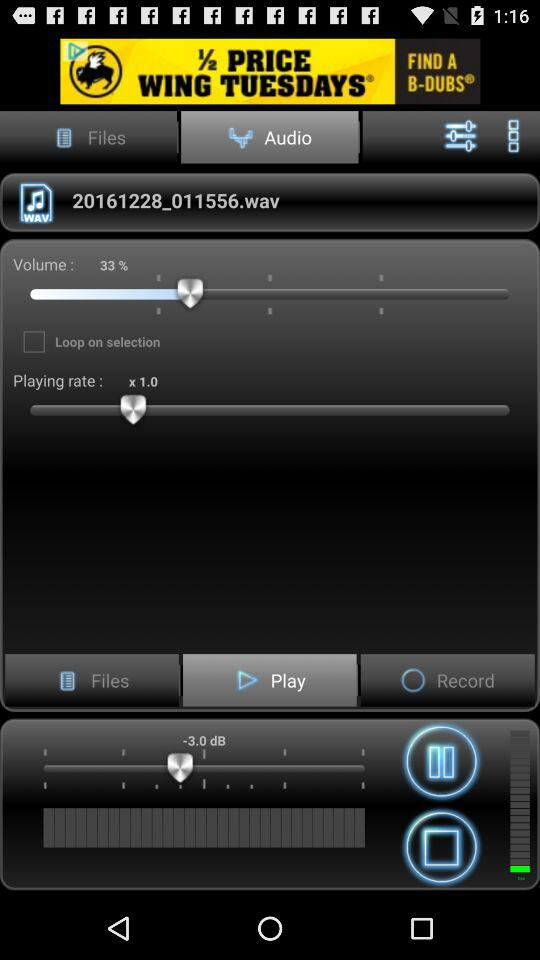What's the status of "Loop on selection"? The status of "Loop on selection" is "off". 